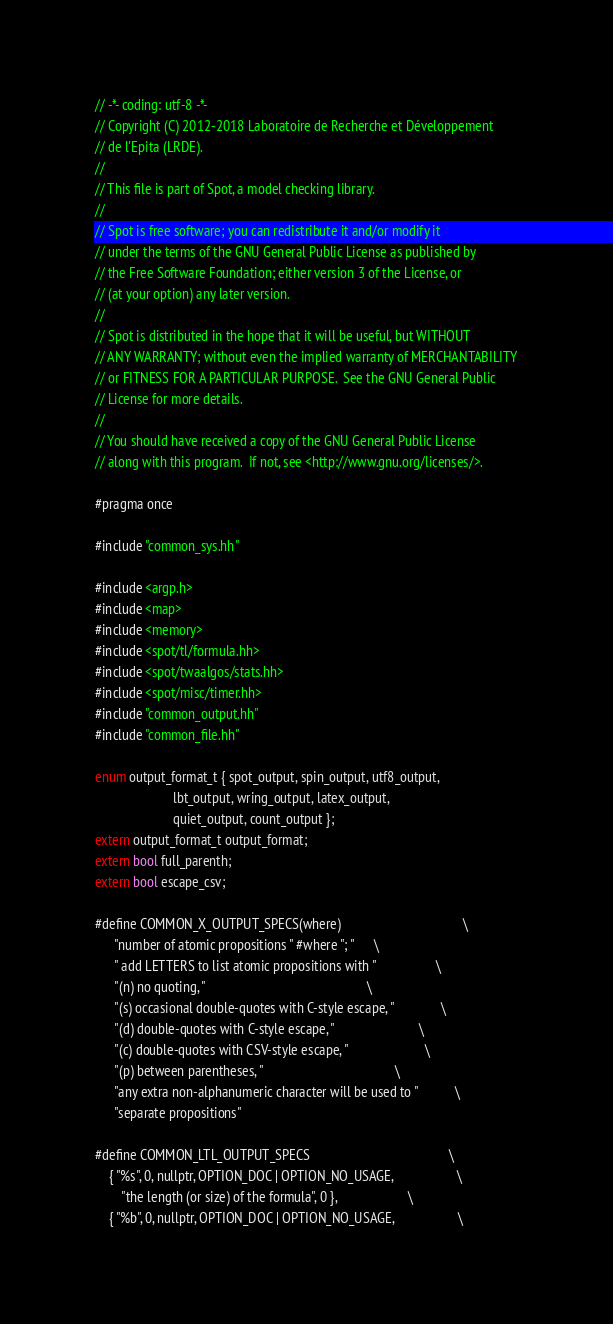Convert code to text. <code><loc_0><loc_0><loc_500><loc_500><_C++_>// -*- coding: utf-8 -*-
// Copyright (C) 2012-2018 Laboratoire de Recherche et Développement
// de l'Epita (LRDE).
//
// This file is part of Spot, a model checking library.
//
// Spot is free software; you can redistribute it and/or modify it
// under the terms of the GNU General Public License as published by
// the Free Software Foundation; either version 3 of the License, or
// (at your option) any later version.
//
// Spot is distributed in the hope that it will be useful, but WITHOUT
// ANY WARRANTY; without even the implied warranty of MERCHANTABILITY
// or FITNESS FOR A PARTICULAR PURPOSE.  See the GNU General Public
// License for more details.
//
// You should have received a copy of the GNU General Public License
// along with this program.  If not, see <http://www.gnu.org/licenses/>.

#pragma once

#include "common_sys.hh"

#include <argp.h>
#include <map>
#include <memory>
#include <spot/tl/formula.hh>
#include <spot/twaalgos/stats.hh>
#include <spot/misc/timer.hh>
#include "common_output.hh"
#include "common_file.hh"

enum output_format_t { spot_output, spin_output, utf8_output,
                       lbt_output, wring_output, latex_output,
                       quiet_output, count_output };
extern output_format_t output_format;
extern bool full_parenth;
extern bool escape_csv;

#define COMMON_X_OUTPUT_SPECS(where)                                    \
      "number of atomic propositions " #where "; "      \
      " add LETTERS to list atomic propositions with "                  \
      "(n) no quoting, "                                                \
      "(s) occasional double-quotes with C-style escape, "              \
      "(d) double-quotes with C-style escape, "                         \
      "(c) double-quotes with CSV-style escape, "                       \
      "(p) between parentheses, "                                       \
      "any extra non-alphanumeric character will be used to "           \
      "separate propositions"

#define COMMON_LTL_OUTPUT_SPECS                                         \
    { "%s", 0, nullptr, OPTION_DOC | OPTION_NO_USAGE,                   \
        "the length (or size) of the formula", 0 },                     \
    { "%b", 0, nullptr, OPTION_DOC | OPTION_NO_USAGE,                   \</code> 